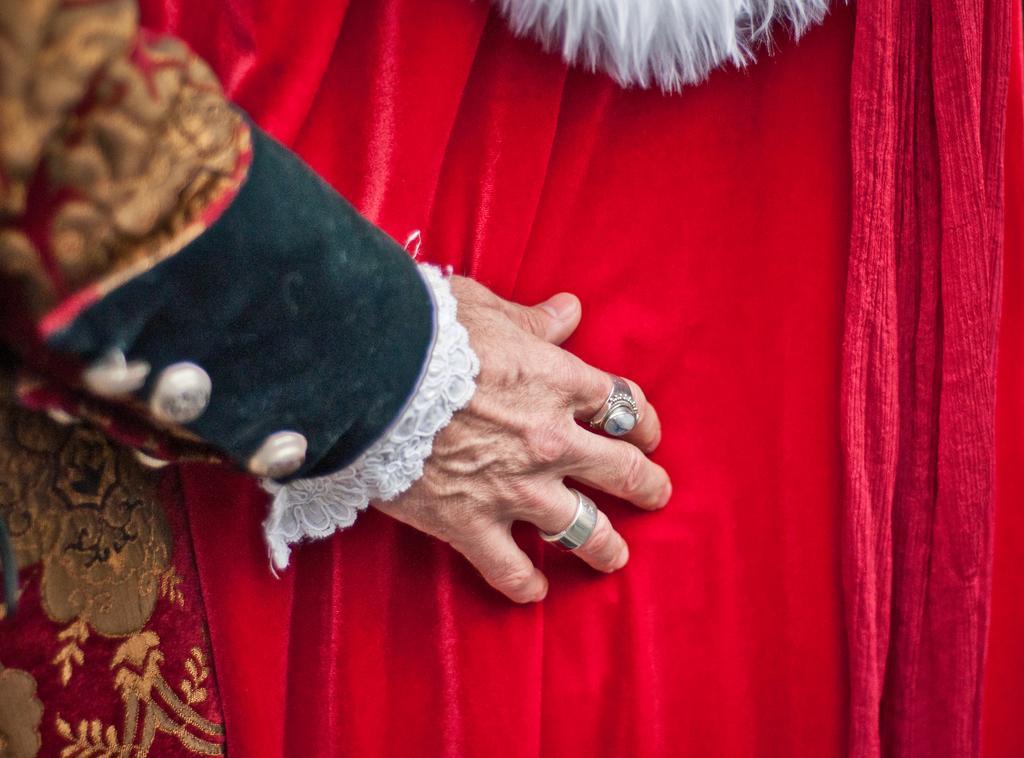Describe this image in one or two sentences. In this picture, there is a hand towards the left and it is placed on the red cloth. To the fingers, there are two rings. 